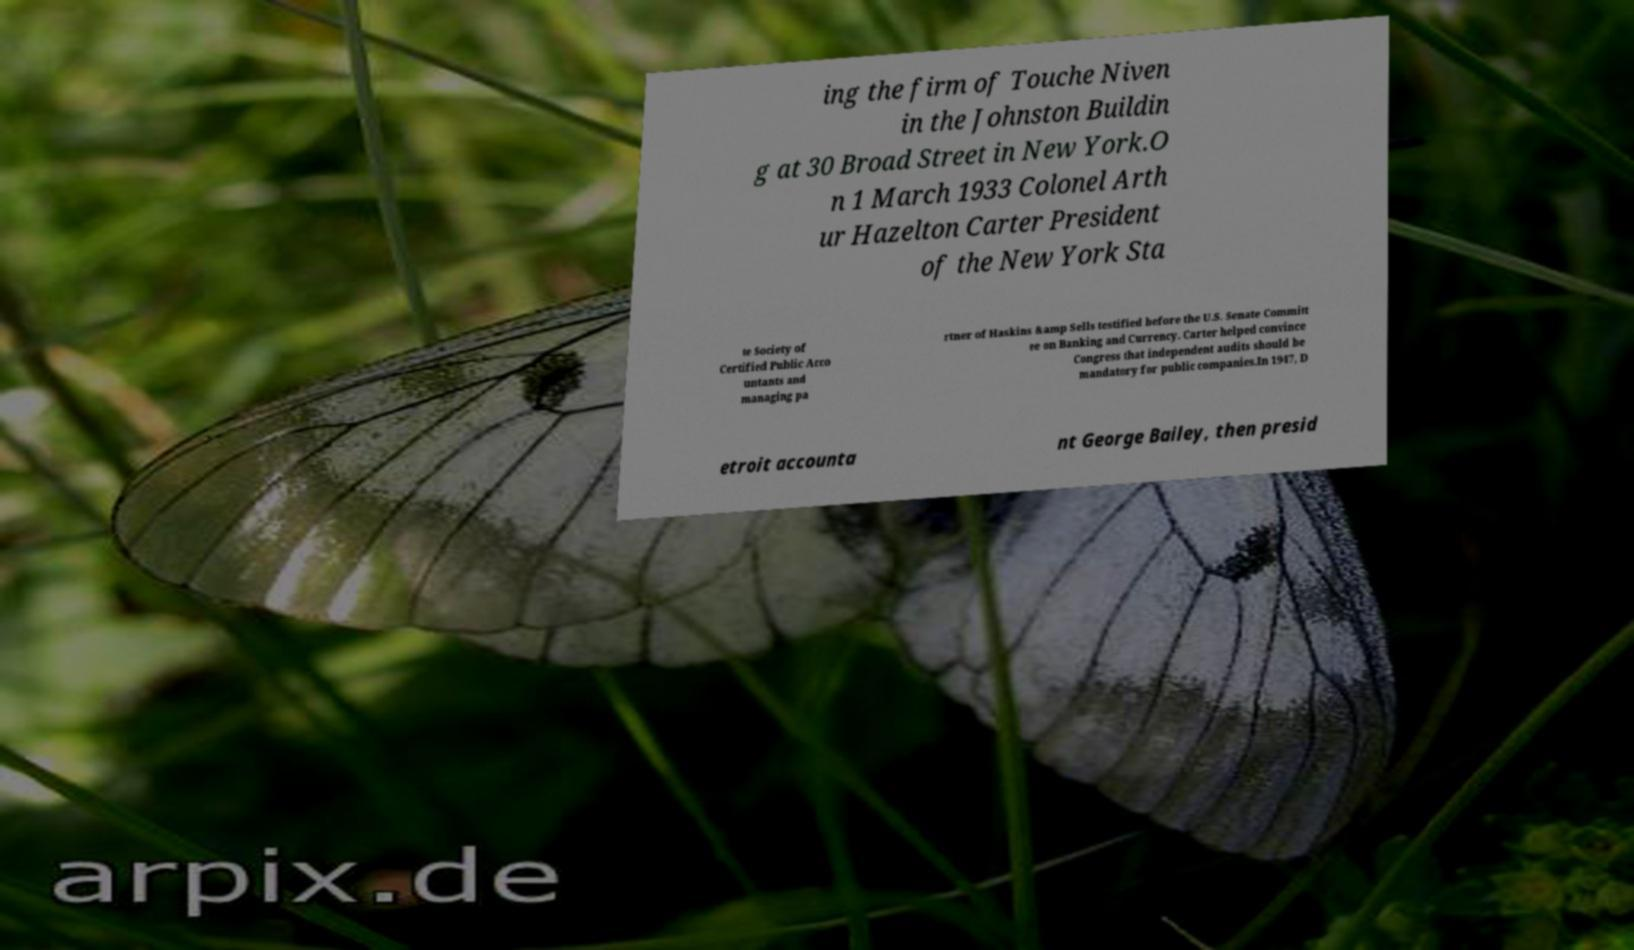Can you accurately transcribe the text from the provided image for me? ing the firm of Touche Niven in the Johnston Buildin g at 30 Broad Street in New York.O n 1 March 1933 Colonel Arth ur Hazelton Carter President of the New York Sta te Society of Certified Public Acco untants and managing pa rtner of Haskins &amp Sells testified before the U.S. Senate Committ ee on Banking and Currency. Carter helped convince Congress that independent audits should be mandatory for public companies.In 1947, D etroit accounta nt George Bailey, then presid 